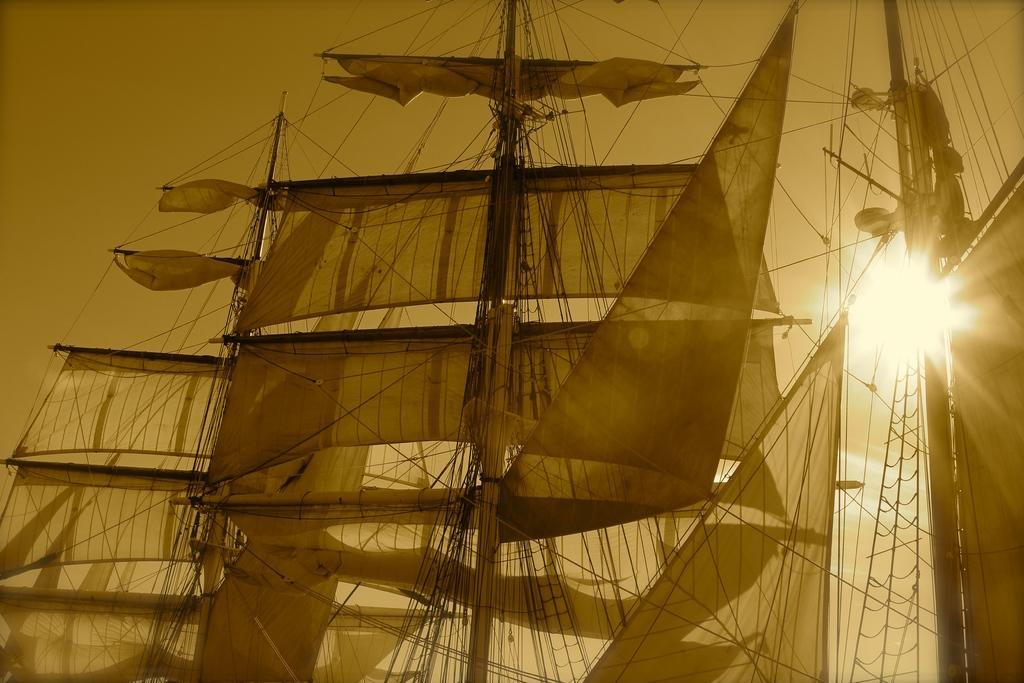Please provide a concise description of this image. In this picture there are boats and there are poles on the boats and there are clothes on the poles and there are tapes. At the top there is sky and there is sun. 